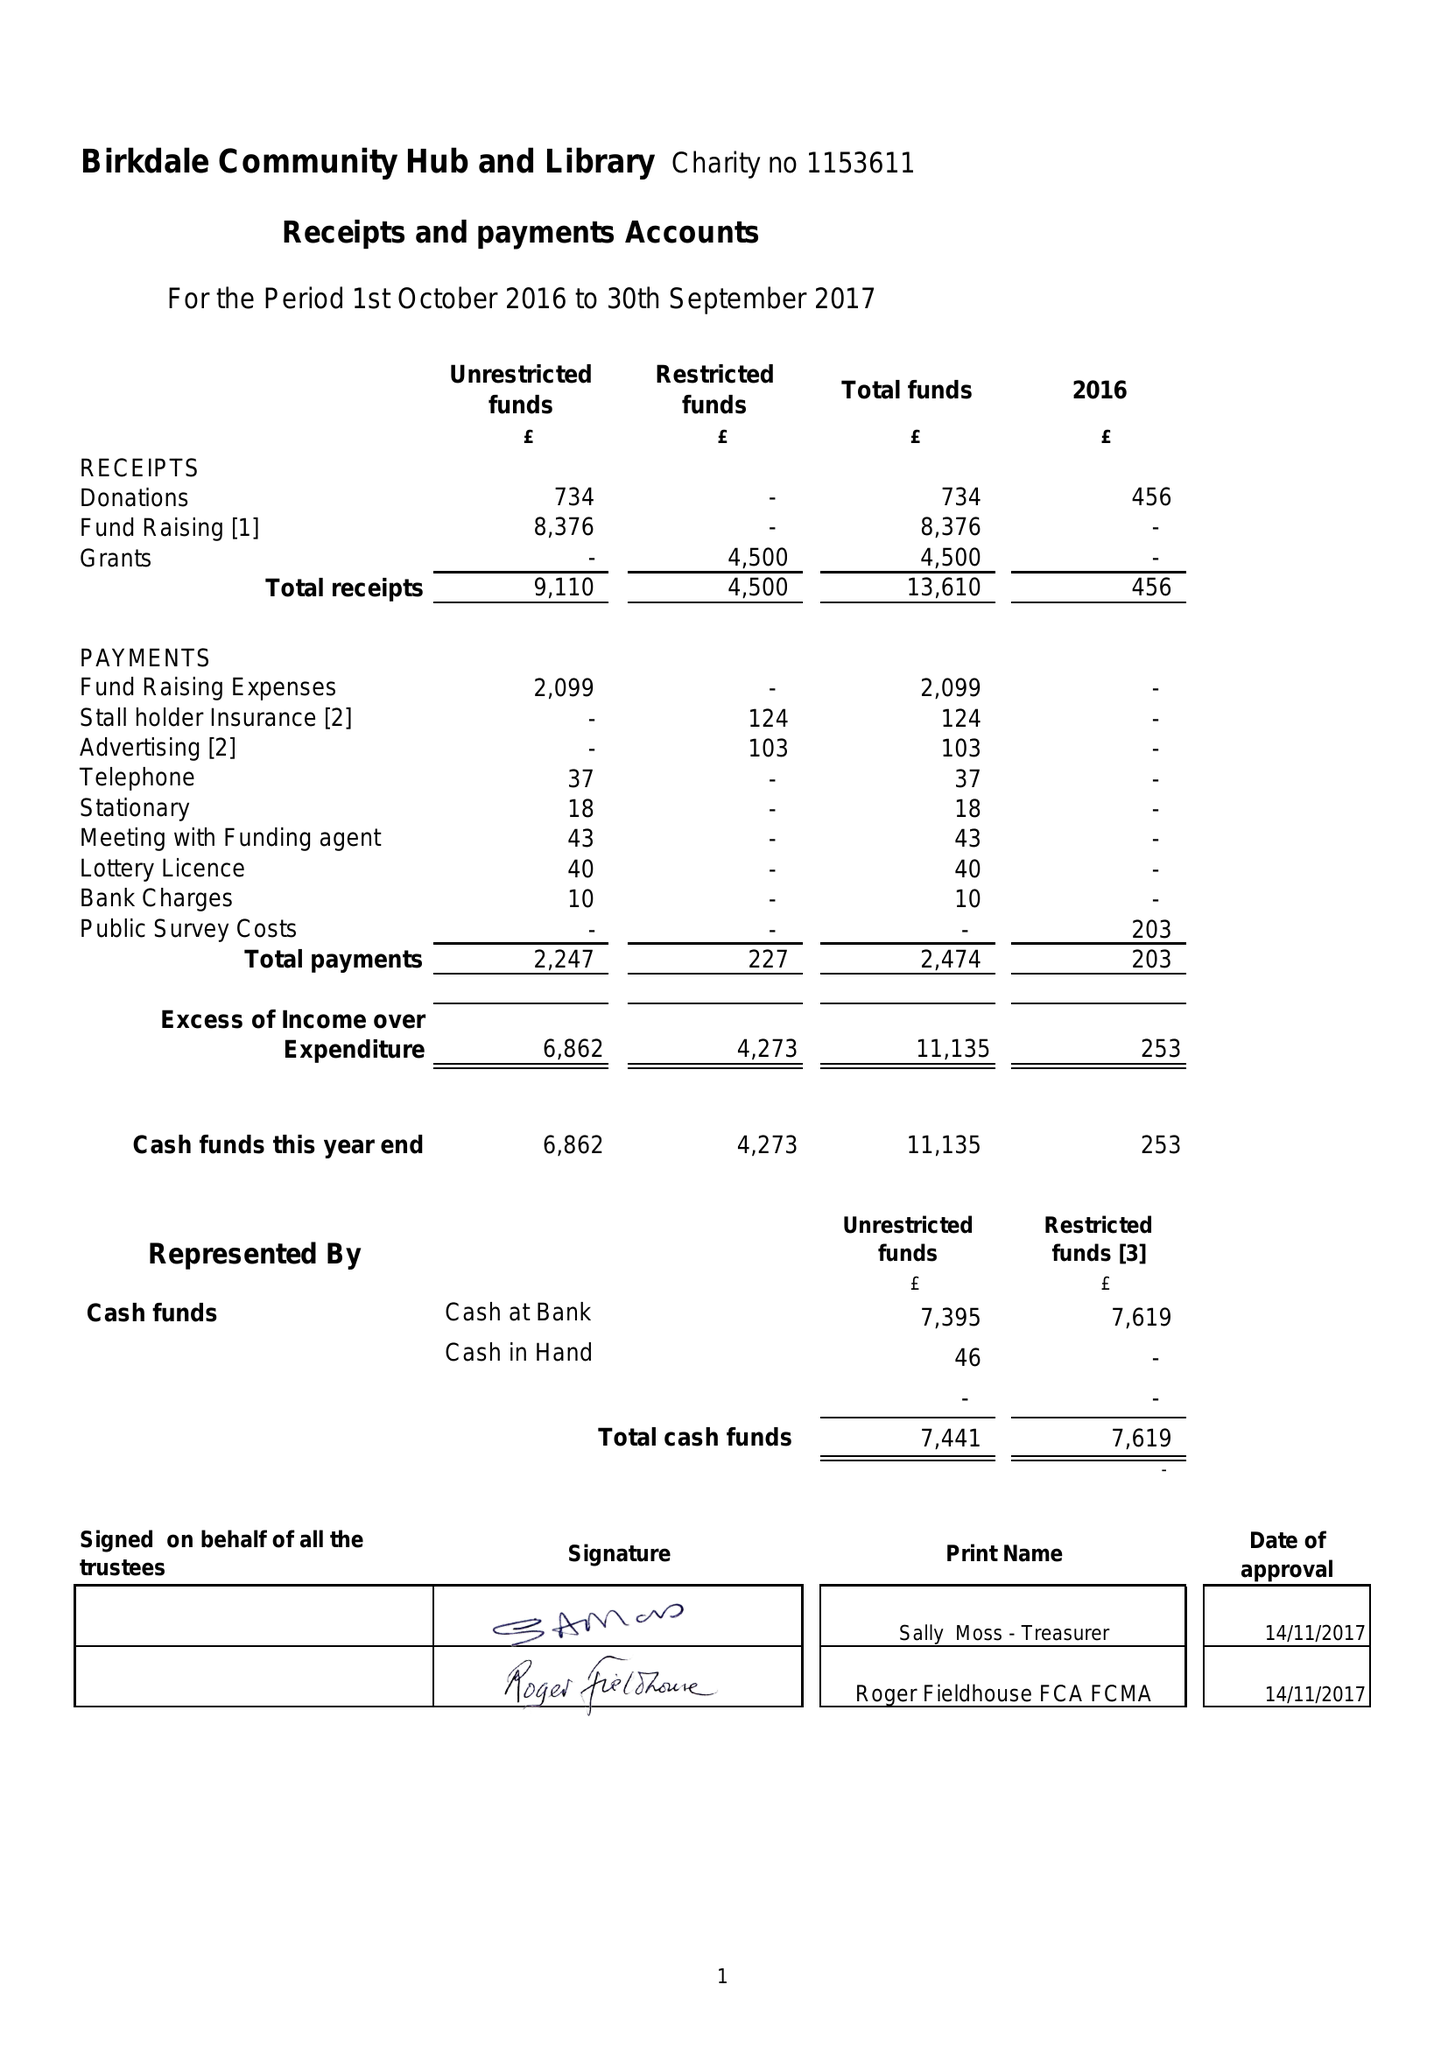What is the value for the address__post_town?
Answer the question using a single word or phrase. SOUTHPORT 